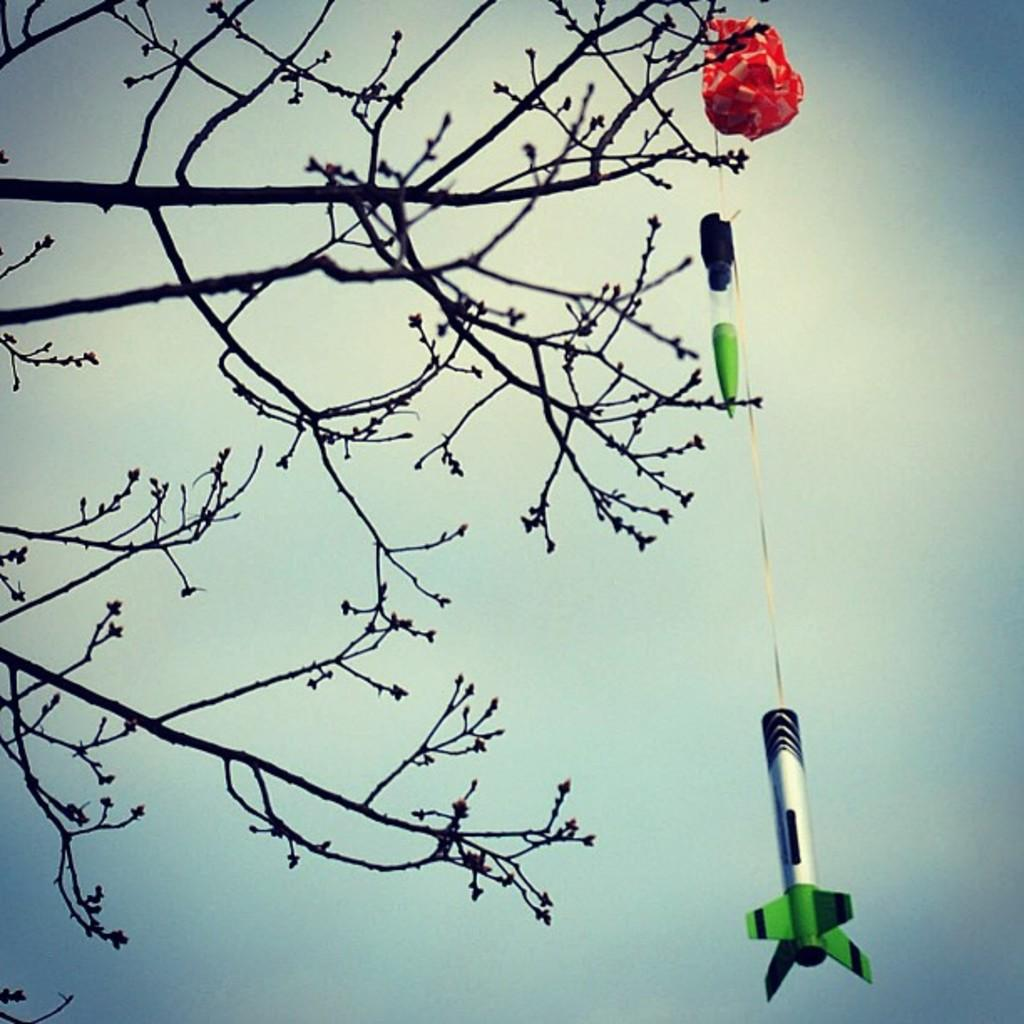What is the main subject of the image? The main subject of the image is a tree stem. What is attached to the tree stem? There is a red, green, and black object attached to the tree stem. What type of book can be seen lying on the ground near the tree stem in the image? There is no book present in the image; it only features a tree stem and a red, green, and black object attached to it. 